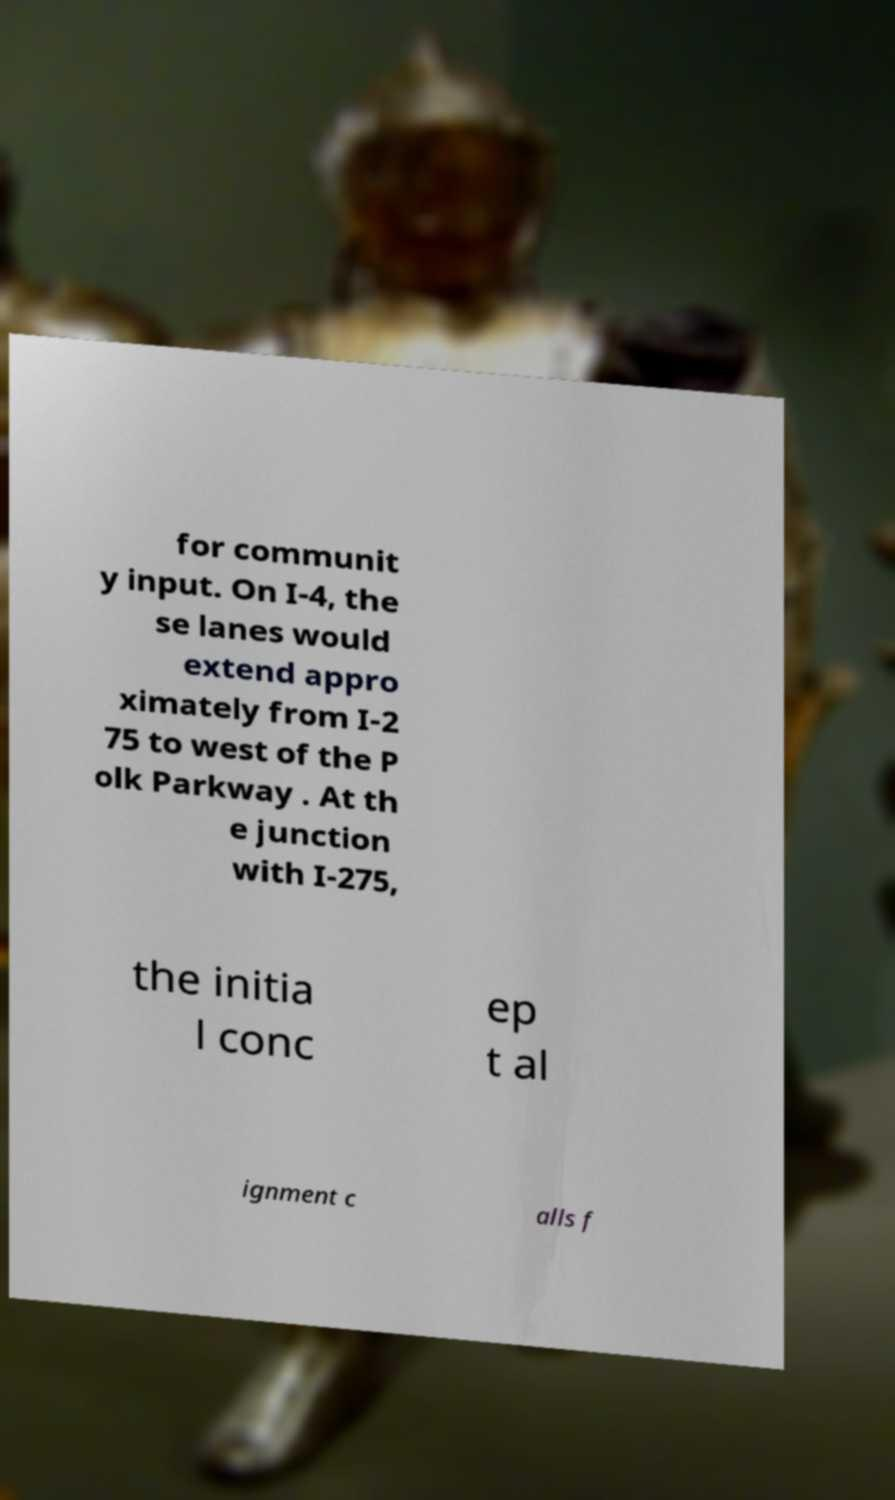Can you read and provide the text displayed in the image?This photo seems to have some interesting text. Can you extract and type it out for me? for communit y input. On I-4, the se lanes would extend appro ximately from I-2 75 to west of the P olk Parkway . At th e junction with I-275, the initia l conc ep t al ignment c alls f 